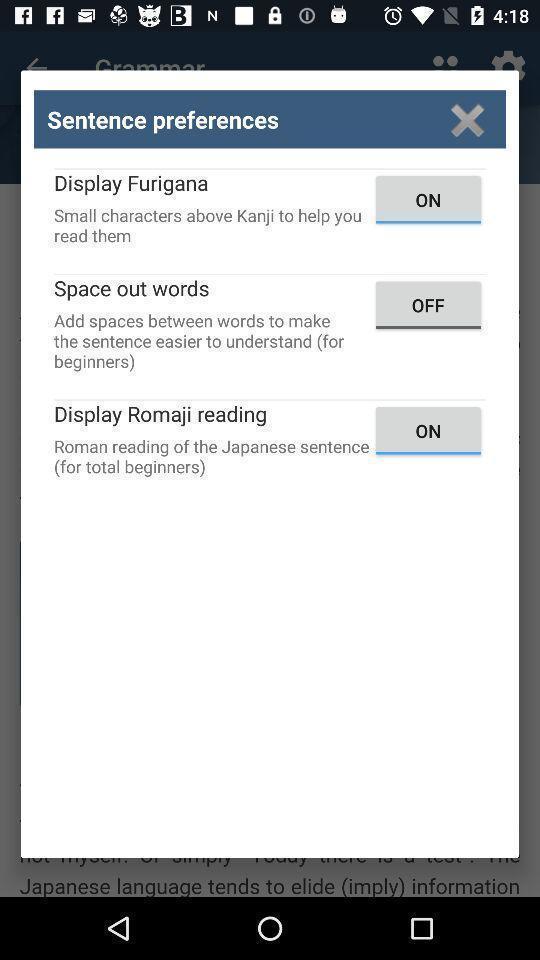Give me a summary of this screen capture. Push up showing options for sentence preferences. 